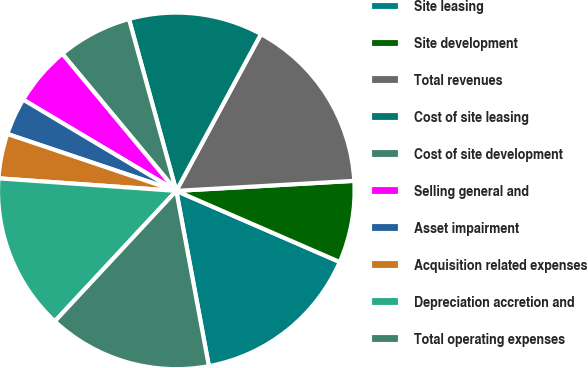Convert chart. <chart><loc_0><loc_0><loc_500><loc_500><pie_chart><fcel>Site leasing<fcel>Site development<fcel>Total revenues<fcel>Cost of site leasing<fcel>Cost of site development<fcel>Selling general and<fcel>Asset impairment<fcel>Acquisition related expenses<fcel>Depreciation accretion and<fcel>Total operating expenses<nl><fcel>15.54%<fcel>7.43%<fcel>16.22%<fcel>12.16%<fcel>6.76%<fcel>5.41%<fcel>3.38%<fcel>4.05%<fcel>14.19%<fcel>14.86%<nl></chart> 